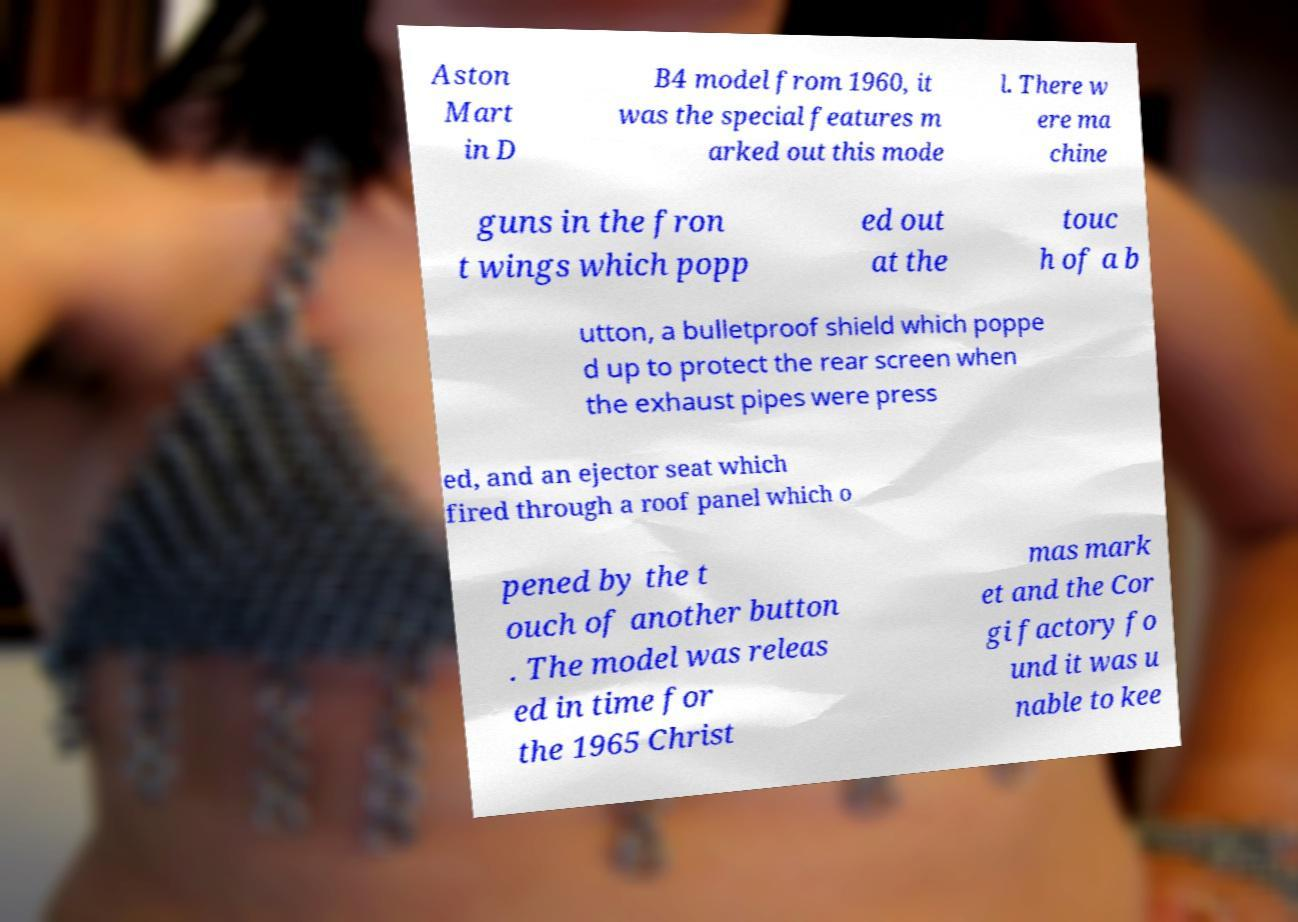Can you accurately transcribe the text from the provided image for me? Aston Mart in D B4 model from 1960, it was the special features m arked out this mode l. There w ere ma chine guns in the fron t wings which popp ed out at the touc h of a b utton, a bulletproof shield which poppe d up to protect the rear screen when the exhaust pipes were press ed, and an ejector seat which fired through a roof panel which o pened by the t ouch of another button . The model was releas ed in time for the 1965 Christ mas mark et and the Cor gi factory fo und it was u nable to kee 